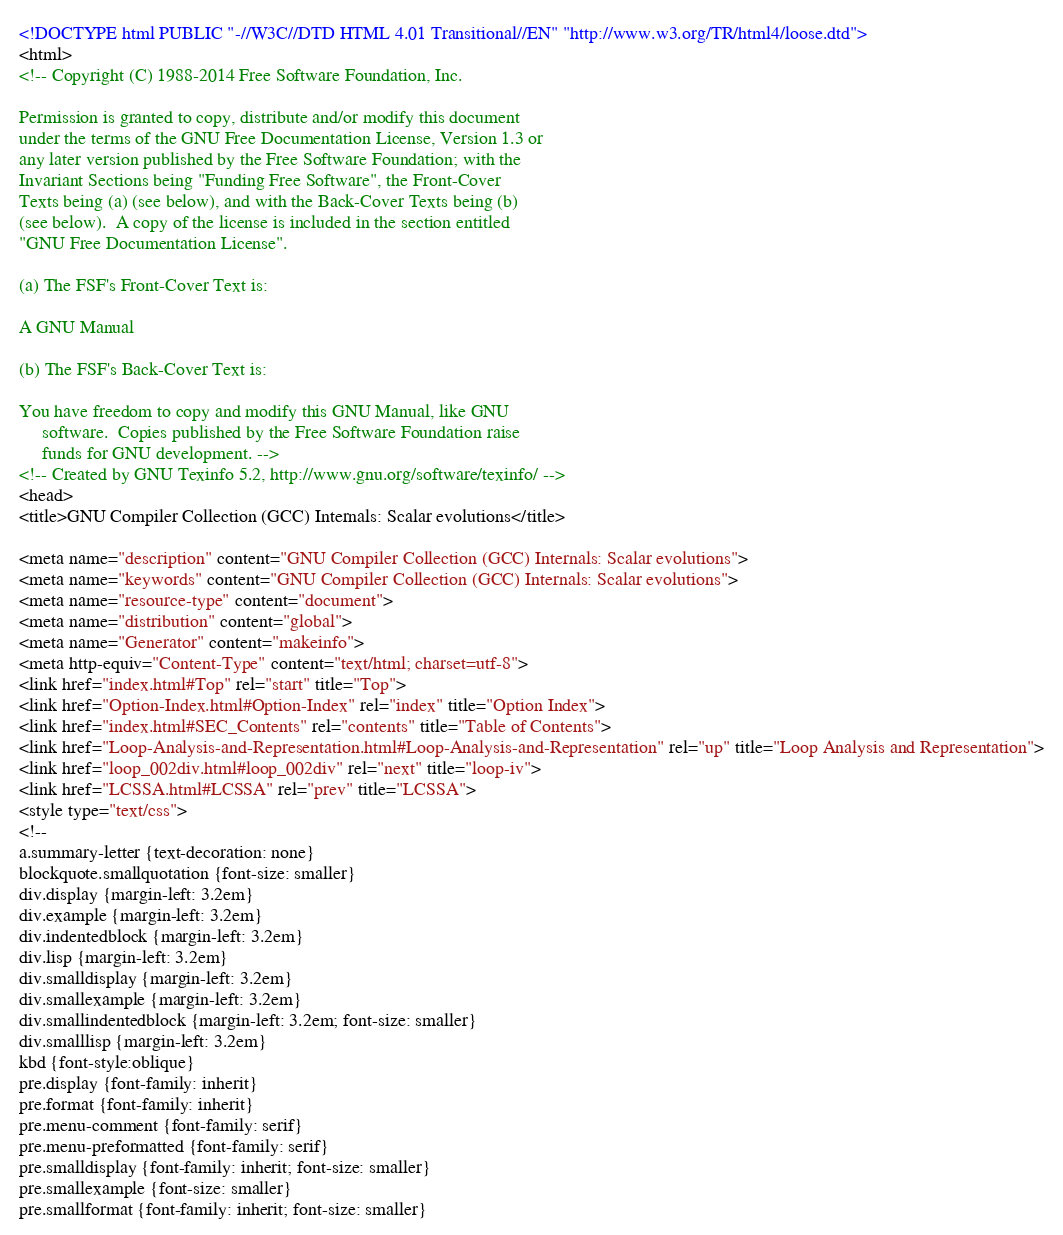Convert code to text. <code><loc_0><loc_0><loc_500><loc_500><_HTML_><!DOCTYPE html PUBLIC "-//W3C//DTD HTML 4.01 Transitional//EN" "http://www.w3.org/TR/html4/loose.dtd">
<html>
<!-- Copyright (C) 1988-2014 Free Software Foundation, Inc.

Permission is granted to copy, distribute and/or modify this document
under the terms of the GNU Free Documentation License, Version 1.3 or
any later version published by the Free Software Foundation; with the
Invariant Sections being "Funding Free Software", the Front-Cover
Texts being (a) (see below), and with the Back-Cover Texts being (b)
(see below).  A copy of the license is included in the section entitled
"GNU Free Documentation License".

(a) The FSF's Front-Cover Text is:

A GNU Manual

(b) The FSF's Back-Cover Text is:

You have freedom to copy and modify this GNU Manual, like GNU
     software.  Copies published by the Free Software Foundation raise
     funds for GNU development. -->
<!-- Created by GNU Texinfo 5.2, http://www.gnu.org/software/texinfo/ -->
<head>
<title>GNU Compiler Collection (GCC) Internals: Scalar evolutions</title>

<meta name="description" content="GNU Compiler Collection (GCC) Internals: Scalar evolutions">
<meta name="keywords" content="GNU Compiler Collection (GCC) Internals: Scalar evolutions">
<meta name="resource-type" content="document">
<meta name="distribution" content="global">
<meta name="Generator" content="makeinfo">
<meta http-equiv="Content-Type" content="text/html; charset=utf-8">
<link href="index.html#Top" rel="start" title="Top">
<link href="Option-Index.html#Option-Index" rel="index" title="Option Index">
<link href="index.html#SEC_Contents" rel="contents" title="Table of Contents">
<link href="Loop-Analysis-and-Representation.html#Loop-Analysis-and-Representation" rel="up" title="Loop Analysis and Representation">
<link href="loop_002div.html#loop_002div" rel="next" title="loop-iv">
<link href="LCSSA.html#LCSSA" rel="prev" title="LCSSA">
<style type="text/css">
<!--
a.summary-letter {text-decoration: none}
blockquote.smallquotation {font-size: smaller}
div.display {margin-left: 3.2em}
div.example {margin-left: 3.2em}
div.indentedblock {margin-left: 3.2em}
div.lisp {margin-left: 3.2em}
div.smalldisplay {margin-left: 3.2em}
div.smallexample {margin-left: 3.2em}
div.smallindentedblock {margin-left: 3.2em; font-size: smaller}
div.smalllisp {margin-left: 3.2em}
kbd {font-style:oblique}
pre.display {font-family: inherit}
pre.format {font-family: inherit}
pre.menu-comment {font-family: serif}
pre.menu-preformatted {font-family: serif}
pre.smalldisplay {font-family: inherit; font-size: smaller}
pre.smallexample {font-size: smaller}
pre.smallformat {font-family: inherit; font-size: smaller}</code> 